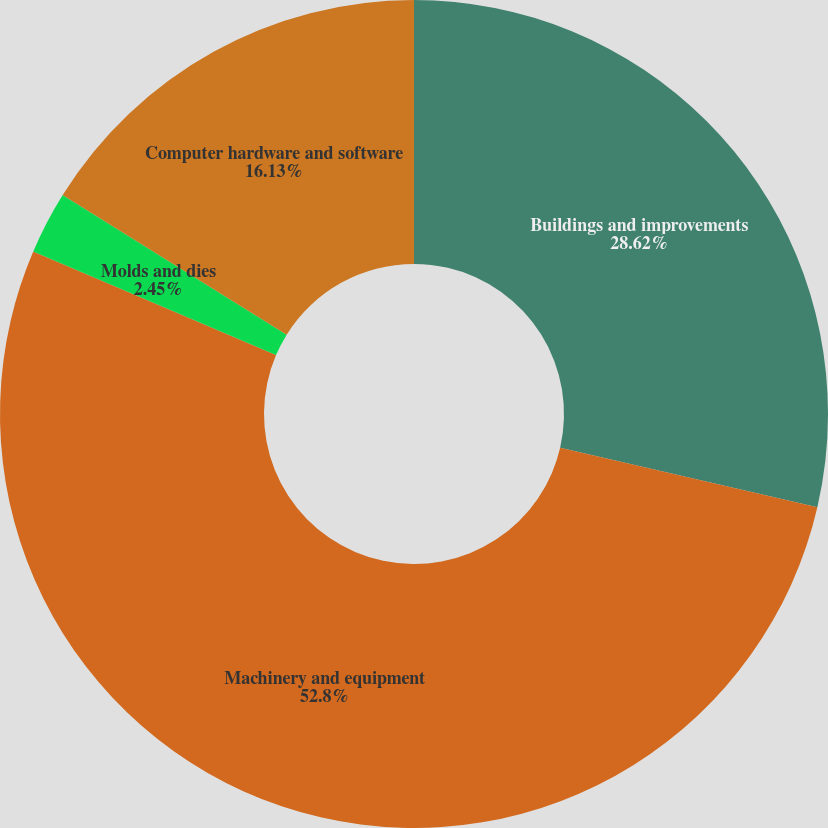Convert chart to OTSL. <chart><loc_0><loc_0><loc_500><loc_500><pie_chart><fcel>Buildings and improvements<fcel>Machinery and equipment<fcel>Molds and dies<fcel>Computer hardware and software<nl><fcel>28.62%<fcel>52.81%<fcel>2.45%<fcel>16.13%<nl></chart> 